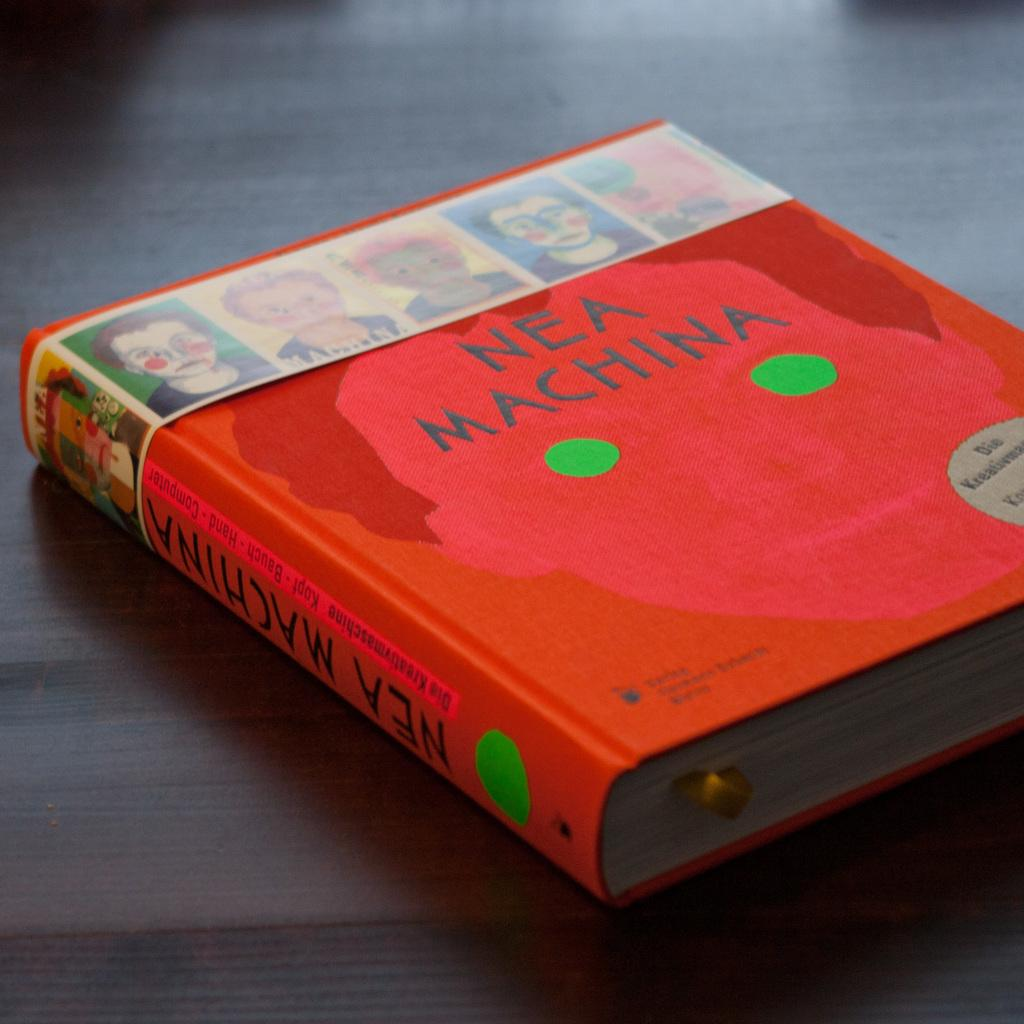<image>
Share a concise interpretation of the image provided. A red book by author Nea Machina has several images of faces on the top sleeve of the book. 